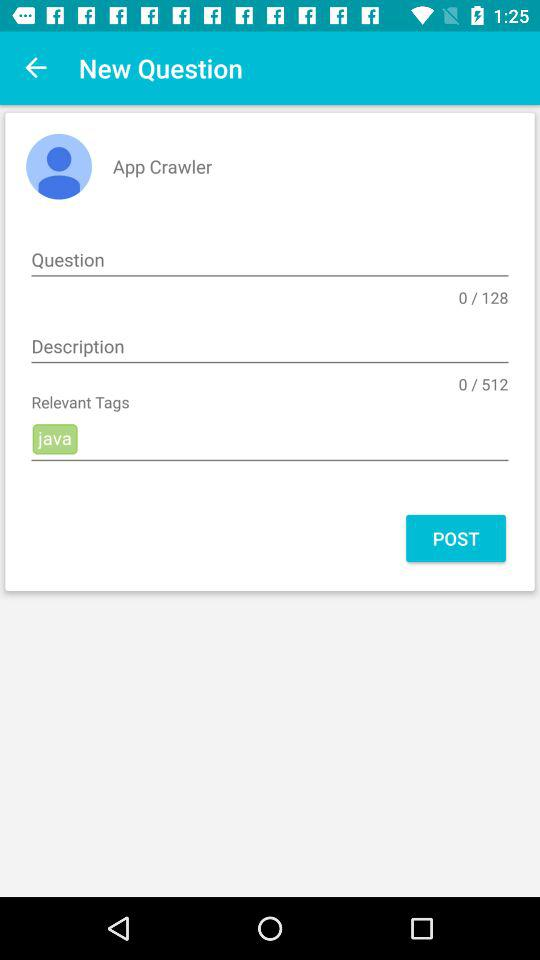In how many words can you ask a question? You can ask a question in 128 words. 